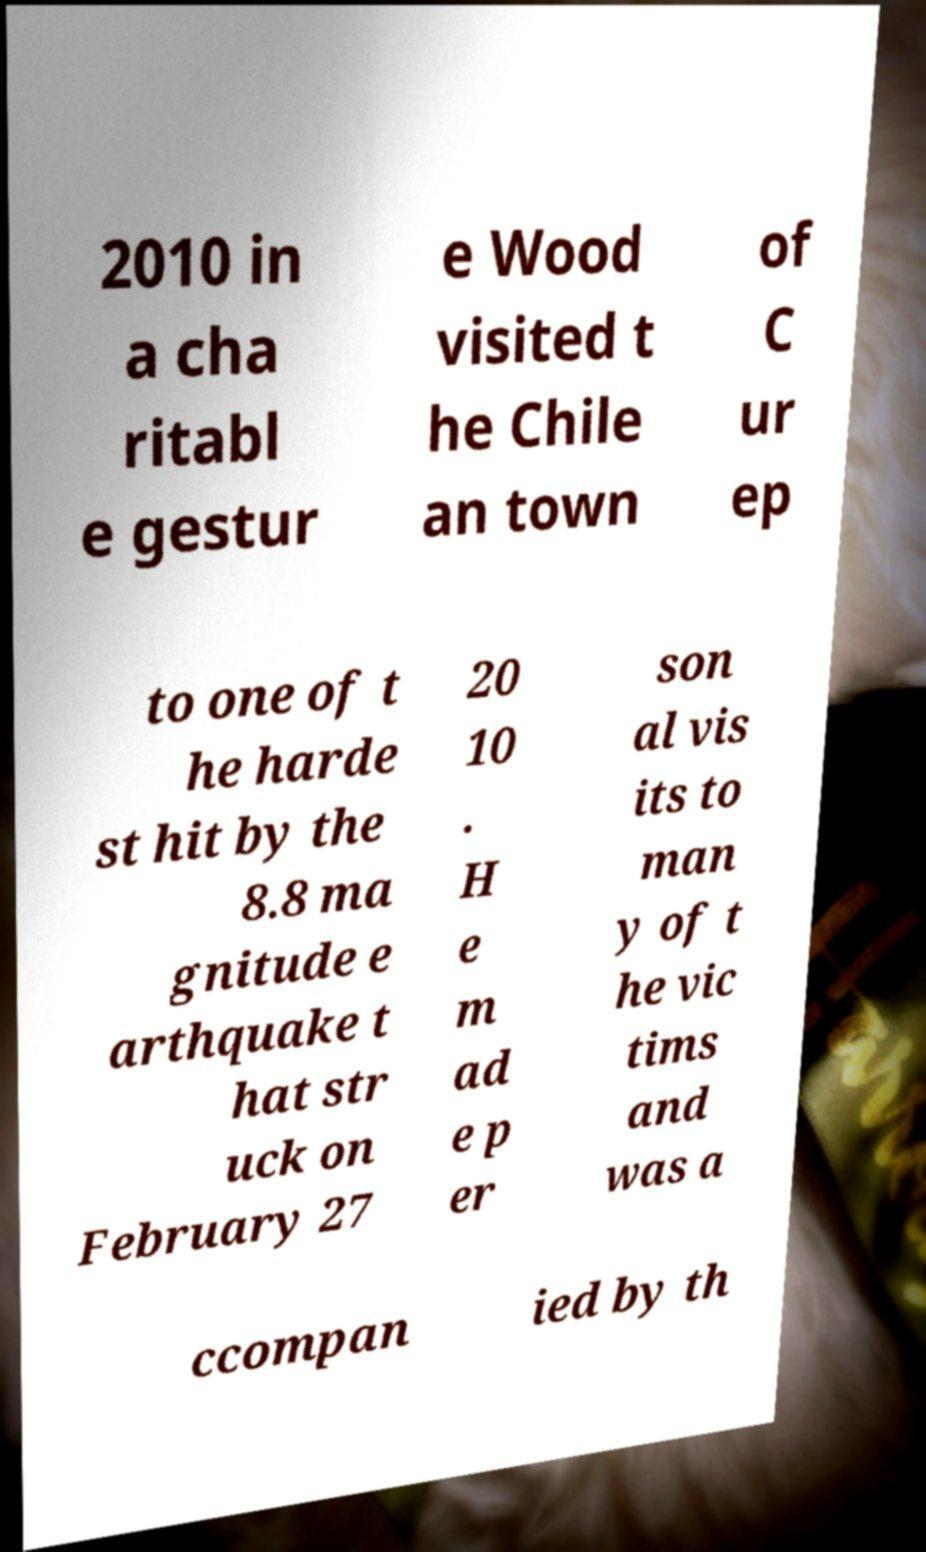Could you assist in decoding the text presented in this image and type it out clearly? 2010 in a cha ritabl e gestur e Wood visited t he Chile an town of C ur ep to one of t he harde st hit by the 8.8 ma gnitude e arthquake t hat str uck on February 27 20 10 . H e m ad e p er son al vis its to man y of t he vic tims and was a ccompan ied by th 